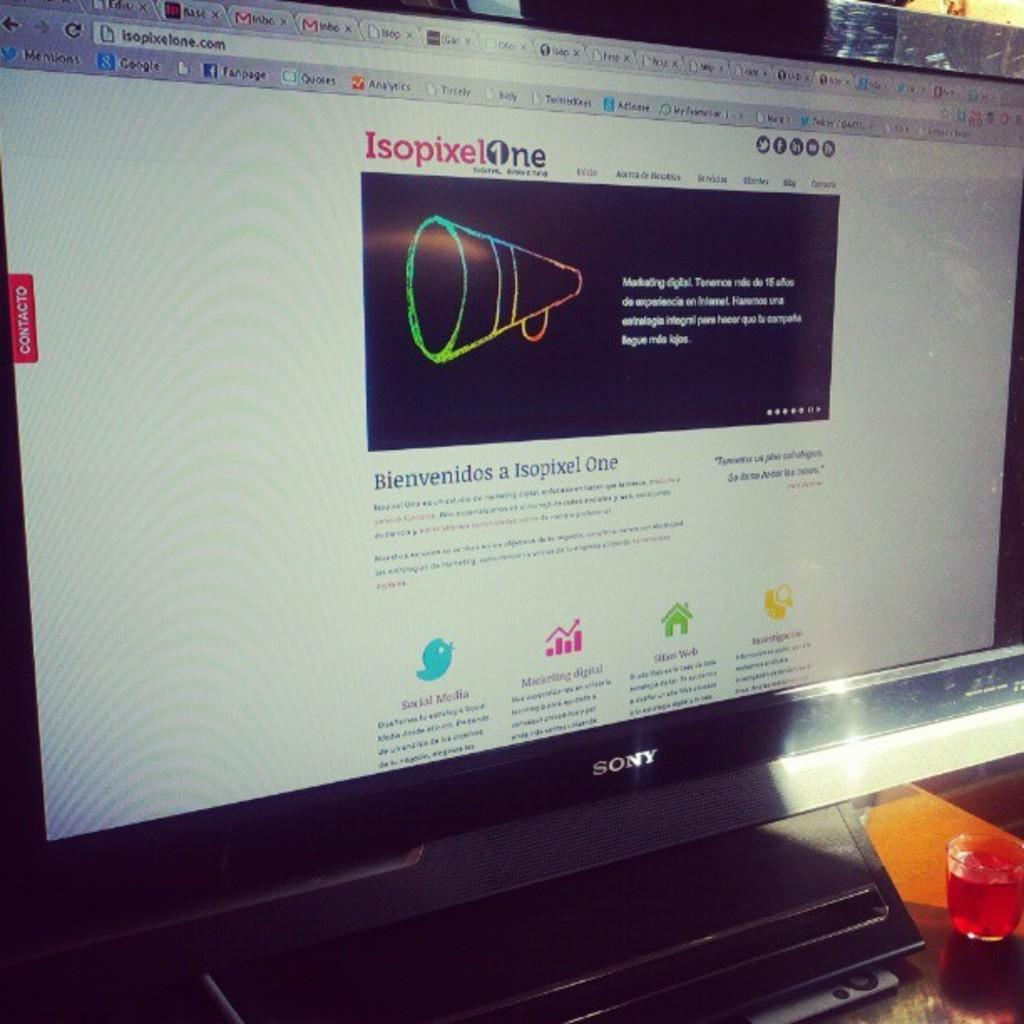<image>
Write a terse but informative summary of the picture. Isopixelone's website is shown on the computer screen in a foreign language. 